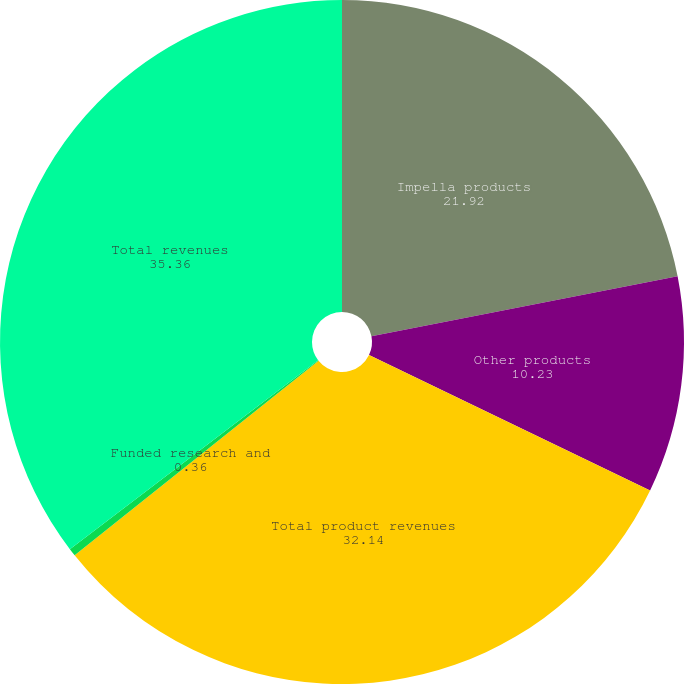Convert chart. <chart><loc_0><loc_0><loc_500><loc_500><pie_chart><fcel>Impella products<fcel>Other products<fcel>Total product revenues<fcel>Funded research and<fcel>Total revenues<nl><fcel>21.92%<fcel>10.23%<fcel>32.14%<fcel>0.36%<fcel>35.36%<nl></chart> 